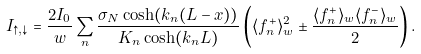<formula> <loc_0><loc_0><loc_500><loc_500>I _ { \uparrow , \downarrow } = \frac { 2 I _ { 0 } } { w } \sum _ { n } \frac { \sigma _ { N } \cosh ( k _ { n } ( L - x ) ) } { K _ { n } \cosh ( k _ { n } L ) } \left ( \langle f _ { n } ^ { + } \rangle ^ { 2 } _ { w } \pm \frac { \langle f _ { n } ^ { + } \rangle _ { w } \langle f _ { n } ^ { - } \rangle _ { w } } { 2 } \right ) .</formula> 